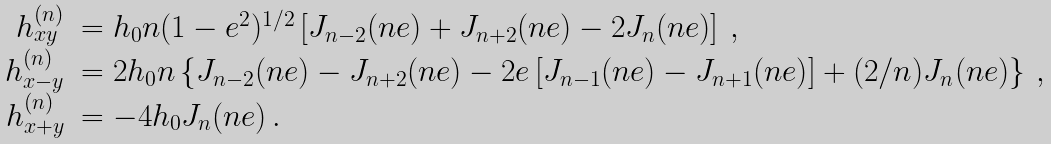Convert formula to latex. <formula><loc_0><loc_0><loc_500><loc_500>\begin{array} { r l } h _ { x y } ^ { ( n ) } & = h _ { 0 } n ( 1 - e ^ { 2 } ) ^ { 1 / 2 } \left [ J _ { n - 2 } ( n e ) + J _ { n + 2 } ( n e ) - 2 J _ { n } ( n e ) \right ] \, , \\ h _ { x - y } ^ { ( n ) } & = 2 h _ { 0 } n \left \{ J _ { n - 2 } ( n e ) - J _ { n + 2 } ( n e ) - 2 e \left [ J _ { n - 1 } ( n e ) - J _ { n + 1 } ( n e ) \right ] + ( 2 / n ) J _ { n } ( n e ) \right \} \, , \\ h _ { x + y } ^ { ( n ) } & = - 4 h _ { 0 } J _ { n } ( n e ) \, . \\ \end{array}</formula> 